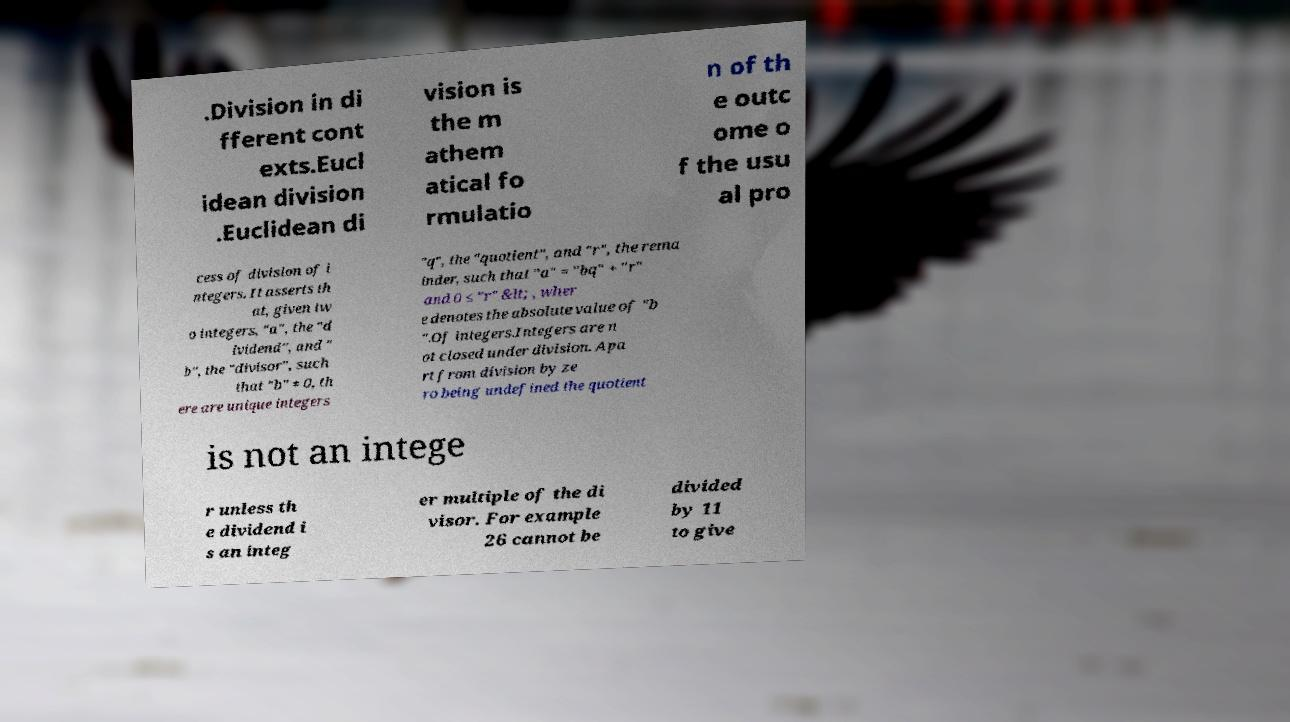Please identify and transcribe the text found in this image. .Division in di fferent cont exts.Eucl idean division .Euclidean di vision is the m athem atical fo rmulatio n of th e outc ome o f the usu al pro cess of division of i ntegers. It asserts th at, given tw o integers, "a", the "d ividend", and " b", the "divisor", such that "b" ≠ 0, th ere are unique integers "q", the "quotient", and "r", the rema inder, such that "a" = "bq" + "r" and 0 ≤ "r" &lt; , wher e denotes the absolute value of "b ".Of integers.Integers are n ot closed under division. Apa rt from division by ze ro being undefined the quotient is not an intege r unless th e dividend i s an integ er multiple of the di visor. For example 26 cannot be divided by 11 to give 